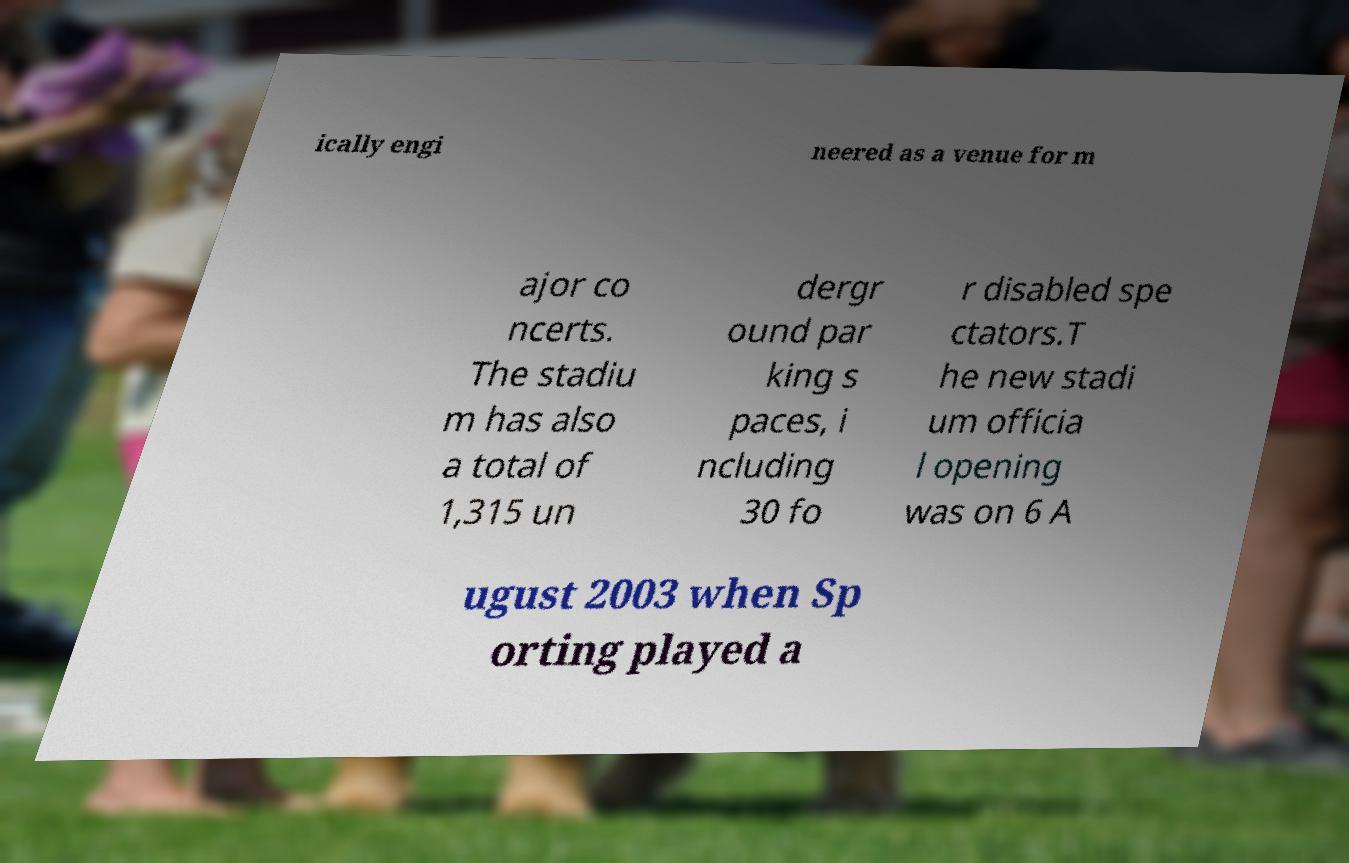Could you assist in decoding the text presented in this image and type it out clearly? ically engi neered as a venue for m ajor co ncerts. The stadiu m has also a total of 1,315 un dergr ound par king s paces, i ncluding 30 fo r disabled spe ctators.T he new stadi um officia l opening was on 6 A ugust 2003 when Sp orting played a 